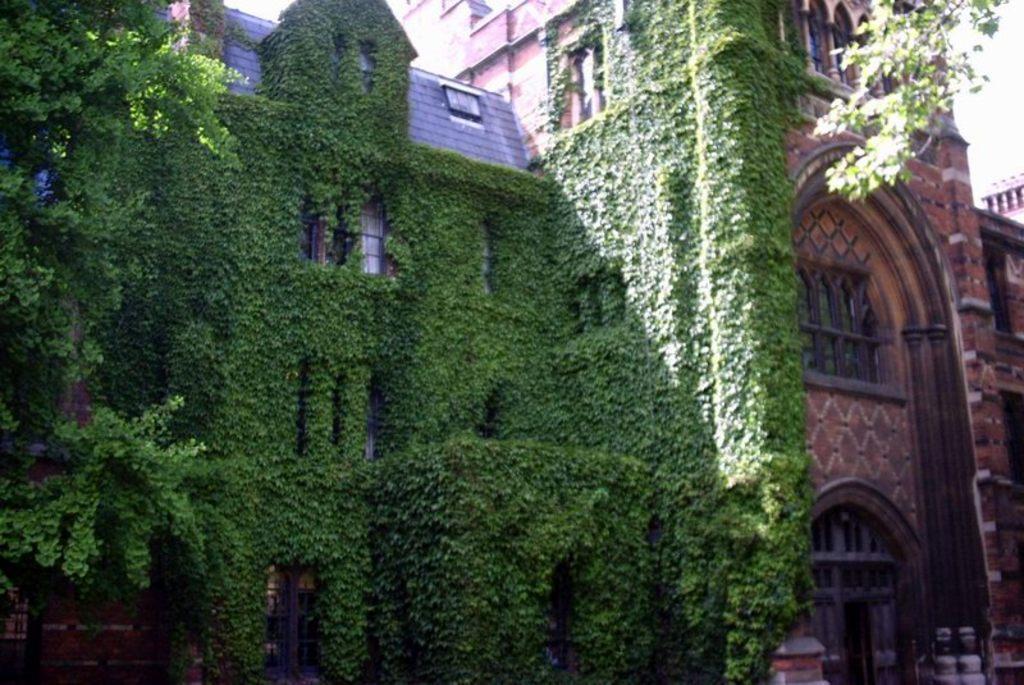Describe this image in one or two sentences. Here in this picture we can see a building with number of windows present over a place and we can see it is fully covered with plants and we can also see trees present. 